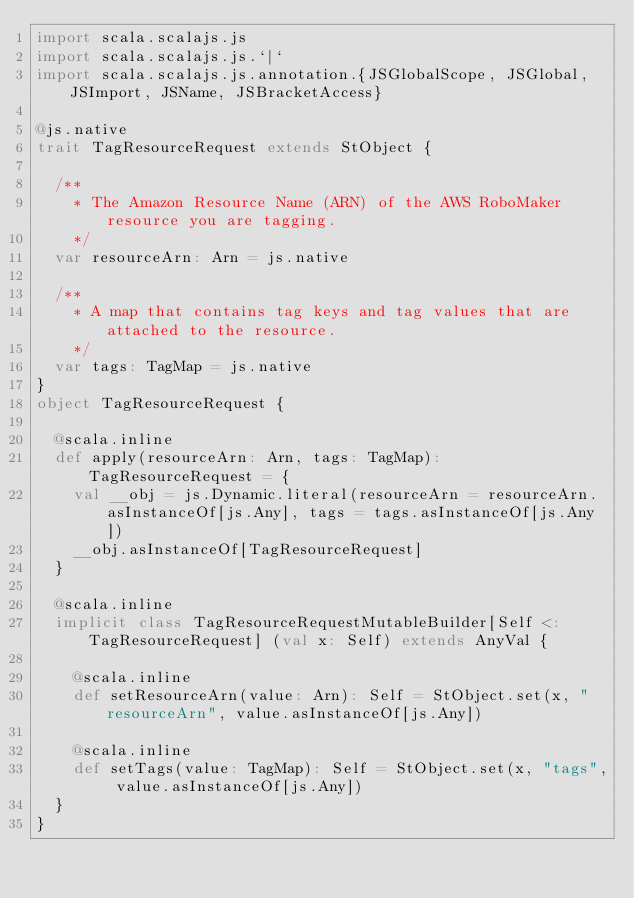<code> <loc_0><loc_0><loc_500><loc_500><_Scala_>import scala.scalajs.js
import scala.scalajs.js.`|`
import scala.scalajs.js.annotation.{JSGlobalScope, JSGlobal, JSImport, JSName, JSBracketAccess}

@js.native
trait TagResourceRequest extends StObject {
  
  /**
    * The Amazon Resource Name (ARN) of the AWS RoboMaker resource you are tagging.
    */
  var resourceArn: Arn = js.native
  
  /**
    * A map that contains tag keys and tag values that are attached to the resource.
    */
  var tags: TagMap = js.native
}
object TagResourceRequest {
  
  @scala.inline
  def apply(resourceArn: Arn, tags: TagMap): TagResourceRequest = {
    val __obj = js.Dynamic.literal(resourceArn = resourceArn.asInstanceOf[js.Any], tags = tags.asInstanceOf[js.Any])
    __obj.asInstanceOf[TagResourceRequest]
  }
  
  @scala.inline
  implicit class TagResourceRequestMutableBuilder[Self <: TagResourceRequest] (val x: Self) extends AnyVal {
    
    @scala.inline
    def setResourceArn(value: Arn): Self = StObject.set(x, "resourceArn", value.asInstanceOf[js.Any])
    
    @scala.inline
    def setTags(value: TagMap): Self = StObject.set(x, "tags", value.asInstanceOf[js.Any])
  }
}
</code> 